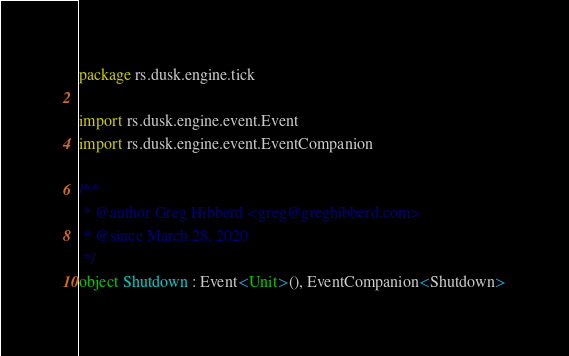Convert code to text. <code><loc_0><loc_0><loc_500><loc_500><_Kotlin_>package rs.dusk.engine.tick

import rs.dusk.engine.event.Event
import rs.dusk.engine.event.EventCompanion

/**
 * @author Greg Hibberd <greg@greghibberd.com>
 * @since March 28, 2020
 */
object Shutdown : Event<Unit>(), EventCompanion<Shutdown></code> 